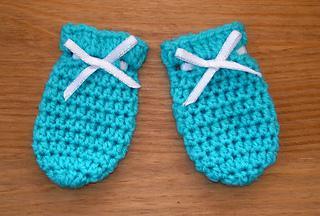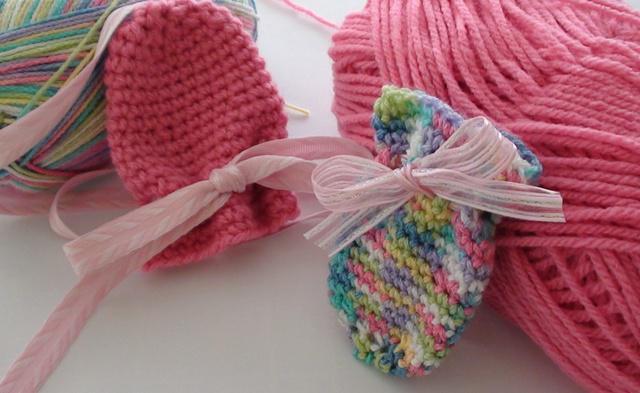The first image is the image on the left, the second image is the image on the right. Evaluate the accuracy of this statement regarding the images: "There are at least 3 pairs of mittens all a different color.". Is it true? Answer yes or no. No. The first image is the image on the left, the second image is the image on the right. Analyze the images presented: Is the assertion "Each image contains at least two baby mittens, and no mittens have separate thumb sections." valid? Answer yes or no. Yes. 